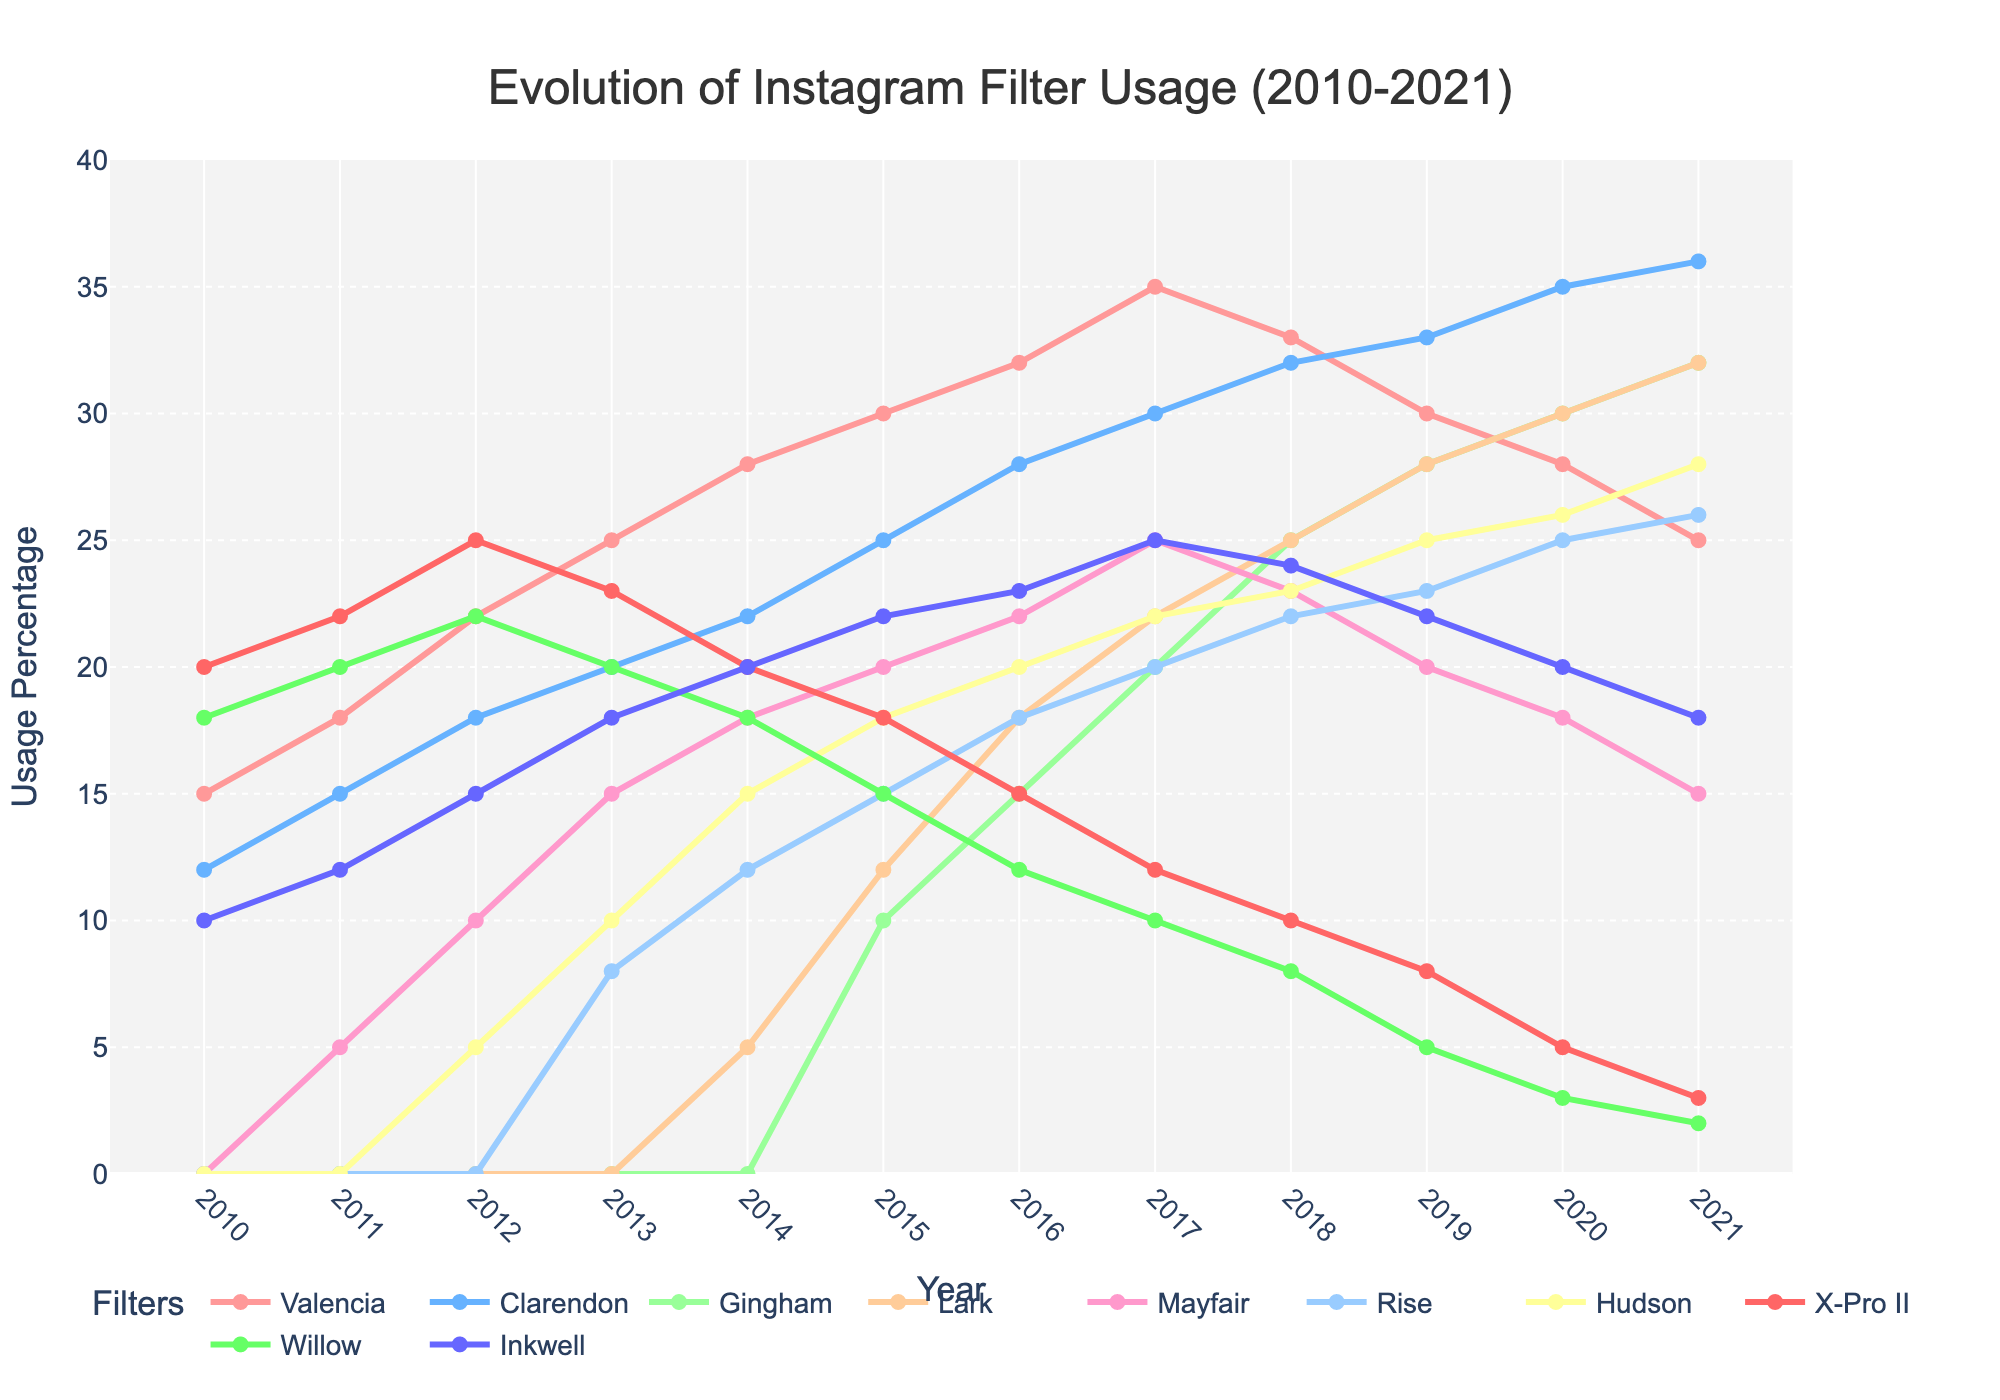What filter had the highest usage in 2010? By observing the leftmost side of the line chart, the filter with the highest percentage in 2010 is X-Pro II (20%).
Answer: X-Pro II Which filter saw the largest increase in usage from 2011 to 2014? Comparing the percentage values from 2011 and 2014, Gingham went from 0% in 2011 to 5% in 2014, so let's compare the other filters: Valencia (18 to 28, +10), Clarendon (15 to 22, +7), Mayfair (5 to 18, +13), and others saw increases but not the largest. Thus, Mayfair had the largest increase of 13%.
Answer: Mayfair What's the average usage percentage of Clarendon between 2017 and 2021? Summing the values of Clarendon from 2017 to 2021 (30 + 32 + 33 + 35 + 36 = 166) and dividing by the number of years (5) gives the average. 166 / 5 = 33.2
Answer: 33.2 Between which years did Gingham see its first appearance on the chart? Gingham first appears at above 0% usage in the year 2015, so by looking at the time span from 2014 to 2015, the initial usage can be observed.
Answer: 2014-2015 How does the usage of Willow in 2020 compare to its usage in 2015? Willow's usage was 3% in 2020 and 15% in 2015 (comparing values of the two years).
Answer: Decreased Which filter had the highest decrease in usage from 2019 to 2021? Checking each filter, we see Valencia (30 to 25, -5), Clarendon (33 to 36, +3), Gingham (28 to 32, +4), etc. The most significant decrease is Willow (5 to 2, -3). By comparison, Gingham and others increased while Willow showed the highest decrease.
Answer: Willow What’s the median usage percentage of Mayfair from 2010 to 2021? Listing the yearly values for Mayfair (0, 5, 10, 15, 18, 20, 22, 23, 20, 18, 15) and finding the middle value in this ordered sequence. The middle value is Mayfair 18 for 2014, 2019, and 2021.
Answer: 18 Between which years did Valencia see the most significant increase in usage? Valencia shows a gradual increase, but between the years 2011 (18%) to 2012 (22%), there is an increase of 4%. No other yearly increase for Valencia is larger than this.
Answer: 2011 to 2012 Which two filters had almost identical usage trends from 2016 to 2021? By comparing visual trends, Lark and Hudson showcase similar up and down trends across respective years (Lark peaks in 2017 and then decreases similarly more or less matching the pattern of Hudson).
Answer: Lark and Hudson Is there any filter that shows a constant increase every single year? Checking each filter, Clarendon shows a consistent upward trend, incrementally increasing every single year from 2010 to 2021.
Answer: Clarendon 